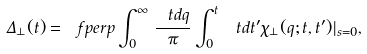Convert formula to latex. <formula><loc_0><loc_0><loc_500><loc_500>\Delta _ { \perp } ( t ) = \ f p e r p \int _ { 0 } ^ { \infty } \, \frac { \ t d q } { \pi } \int _ { 0 } ^ { t } \, \ t d t ^ { \prime } \chi _ { \perp } ( q ; t , t ^ { \prime } ) | _ { s = 0 } ,</formula> 